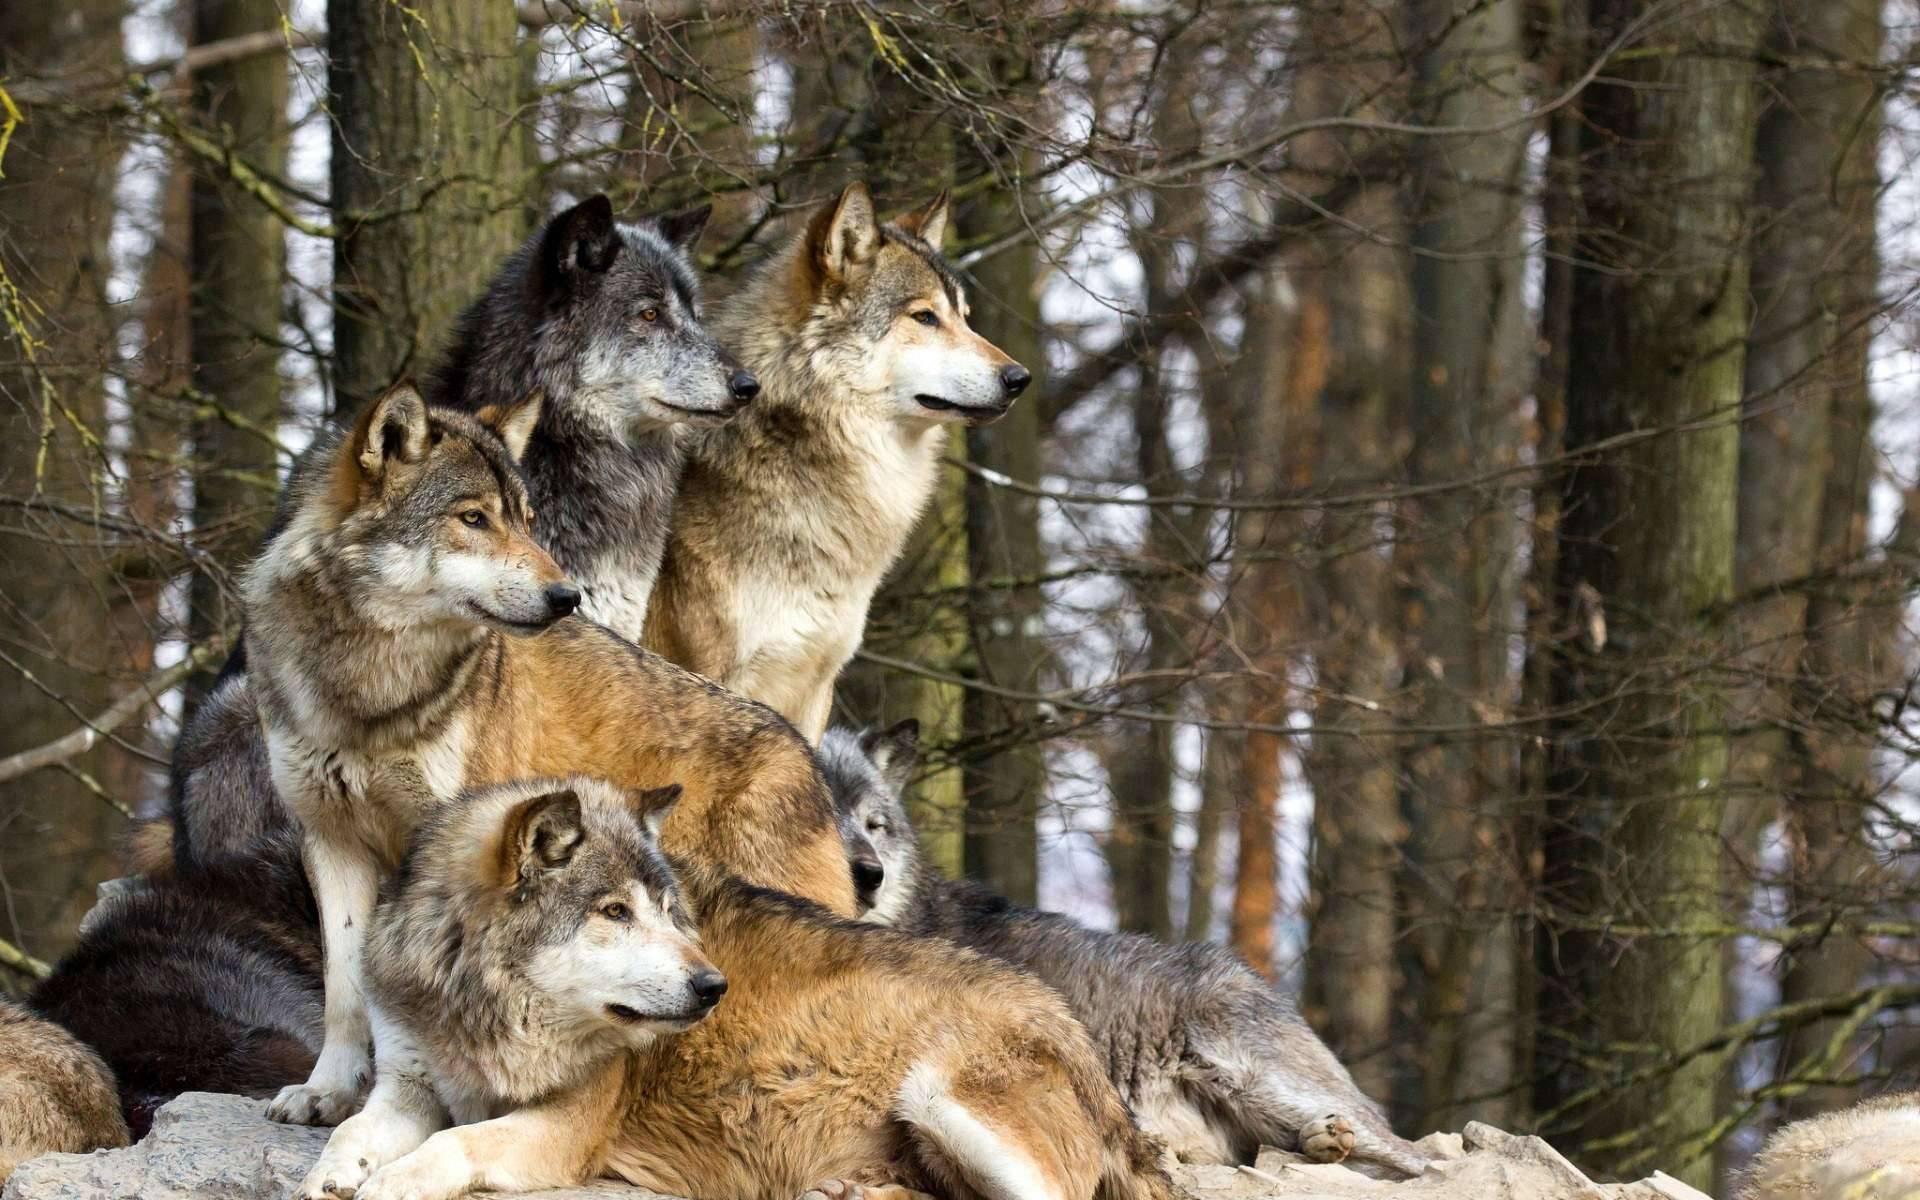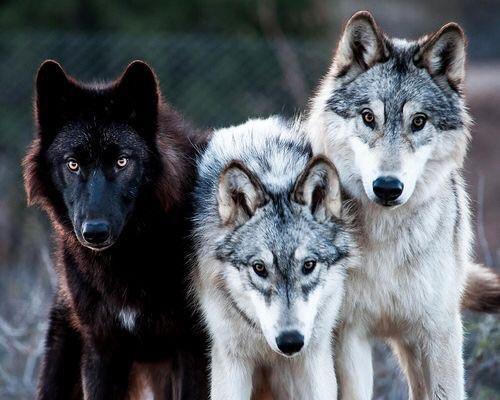The first image is the image on the left, the second image is the image on the right. Considering the images on both sides, is "The image on the right contains exactly one black wolf" valid? Answer yes or no. Yes. The first image is the image on the left, the second image is the image on the right. Analyze the images presented: Is the assertion "The image on the right contains one wolf with a black colored head." valid? Answer yes or no. Yes. 